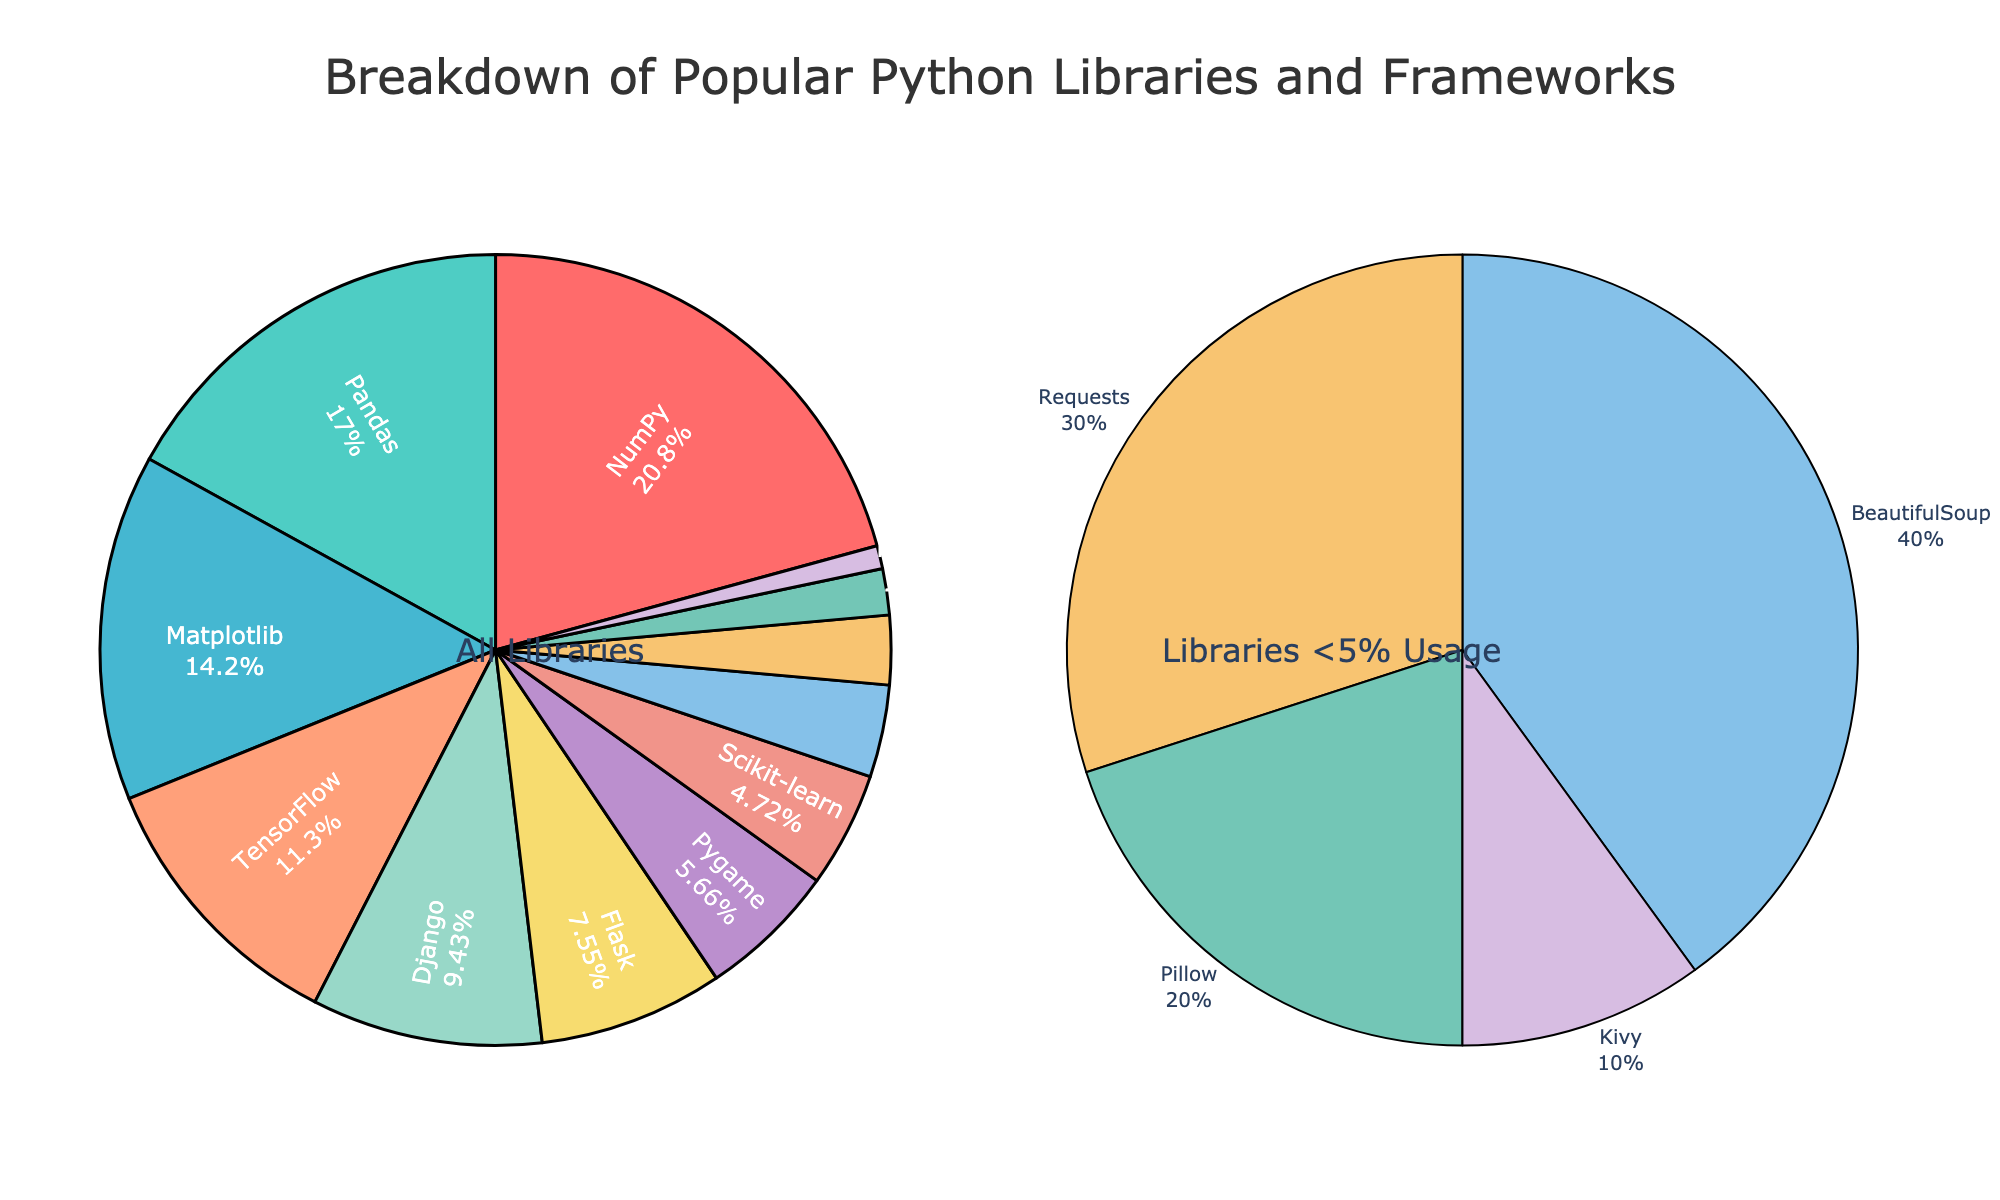Which library has the highest usage percentage? According to the figure, the library with the highest usage percentage is the largest slice in the main pie chart. The label "NumPy" is attached to this slice.
Answer: NumPy Which library has the smallest slice in the "All Libraries" pie chart? Looking at the main pie chart, the smallest slice is labeled "Kivy", indicating it has the smallest usage percentage.
Answer: Kivy What is the combined usage percentage of Pandas and Matplotlib? The figure shows Pandas at 18% and Matplotlib at 15%. To find the combined usage, we add 18% (Pandas) and 15% (Matplotlib). 18 + 15 = 33
Answer: 33% Which libraries are shown in the smaller pie chart? The smaller pie chart displays the libraries with less than 5% usage. From the figure, these are Scikit-learn, BeautifulSoup, Requests, Pillow, and Kivy.
Answer: Scikit-learn, BeautifulSoup, Requests, Pillow, Kivy Is TensorFlow usage greater than Django usage? Referring to the main pie chart, TensorFlow is labeled with 12% and Django with 10%. Since 12% is greater than 10%, TensorFlow has higher usage than Django.
Answer: Yes What is the total usage percentage of libraries that have less than 5% usage? The smaller pie chart shows the percentages for libraries with less than 5% usage: Scikit-learn 5%, BeautifulSoup 4%, Requests 3%, Pillow 2%, Kivy 1%. Adding these percentages: 5 + 4 + 3 + 2 + 1 = 15
Answer: 15% Which library is represented by the green color in the main pie chart? In the main pie chart, the second largest slice colored green is labeled "Pandas".
Answer: Pandas How many libraries have usage percentages greater than 10%? Viewing the main pie chart, the libraries exceeding 10% are NumPy (22%), Pandas (18%), Matplotlib (15%), and TensorFlow (12%). Hence, there are four libraries in this category.
Answer: 4 How does the usage of Django compare to Flask? In the figure, the main pie chart shows Django at 10% and Flask at 8%. Since 10% is greater than 8%, Django has higher usage compared to Flask.
Answer: Django What is the average usage percentage of NumPy, Pandas, and Matplotlib combined? The percentages for NumPy, Pandas, and Matplotlib are 22%, 18%, and 15%, respectively. To find the average: (22 + 18 + 15)/3. Calculating the sum: 22 + 18 + 15 = 55. Dividing by 3 gives 55/3 = 18.33
Answer: 18.33 